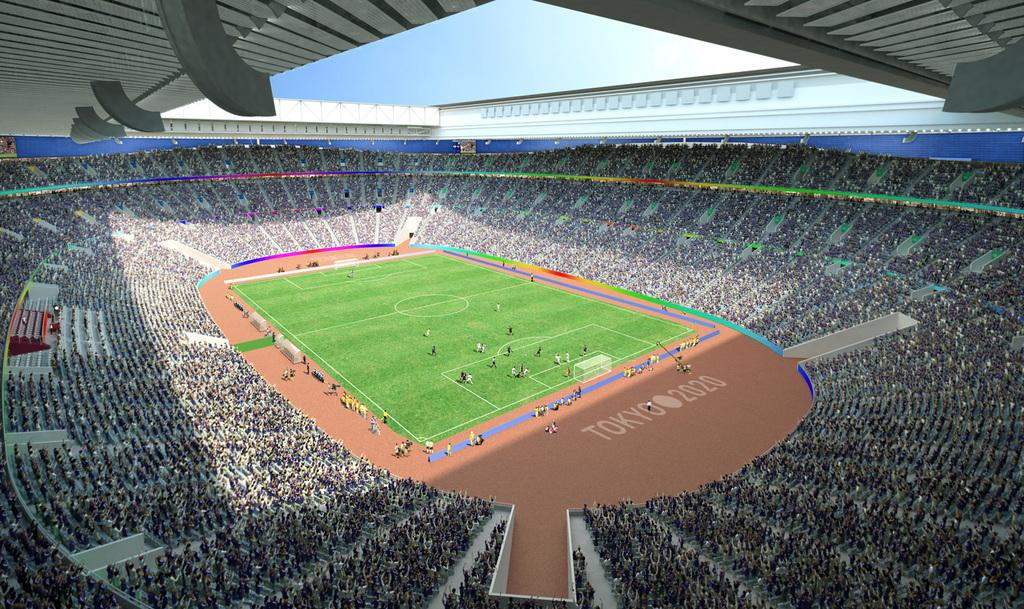What type of location is depicted in the image? The image shows the interior view of a stadium. What can be seen on the ground in the image? There is a ground visible in the image. How many people are present in the image? There are a few people in the image. What type of surface is visible on the ground level? There is grass visible in the image. What is visible in the background of the image? The sky is visible in the image. What type of scarf is being used to cover the camera in the image? There is no camera or scarf present in the image. How does the wound on the person's arm look like in the image? There is no wound visible on any person in the image. 